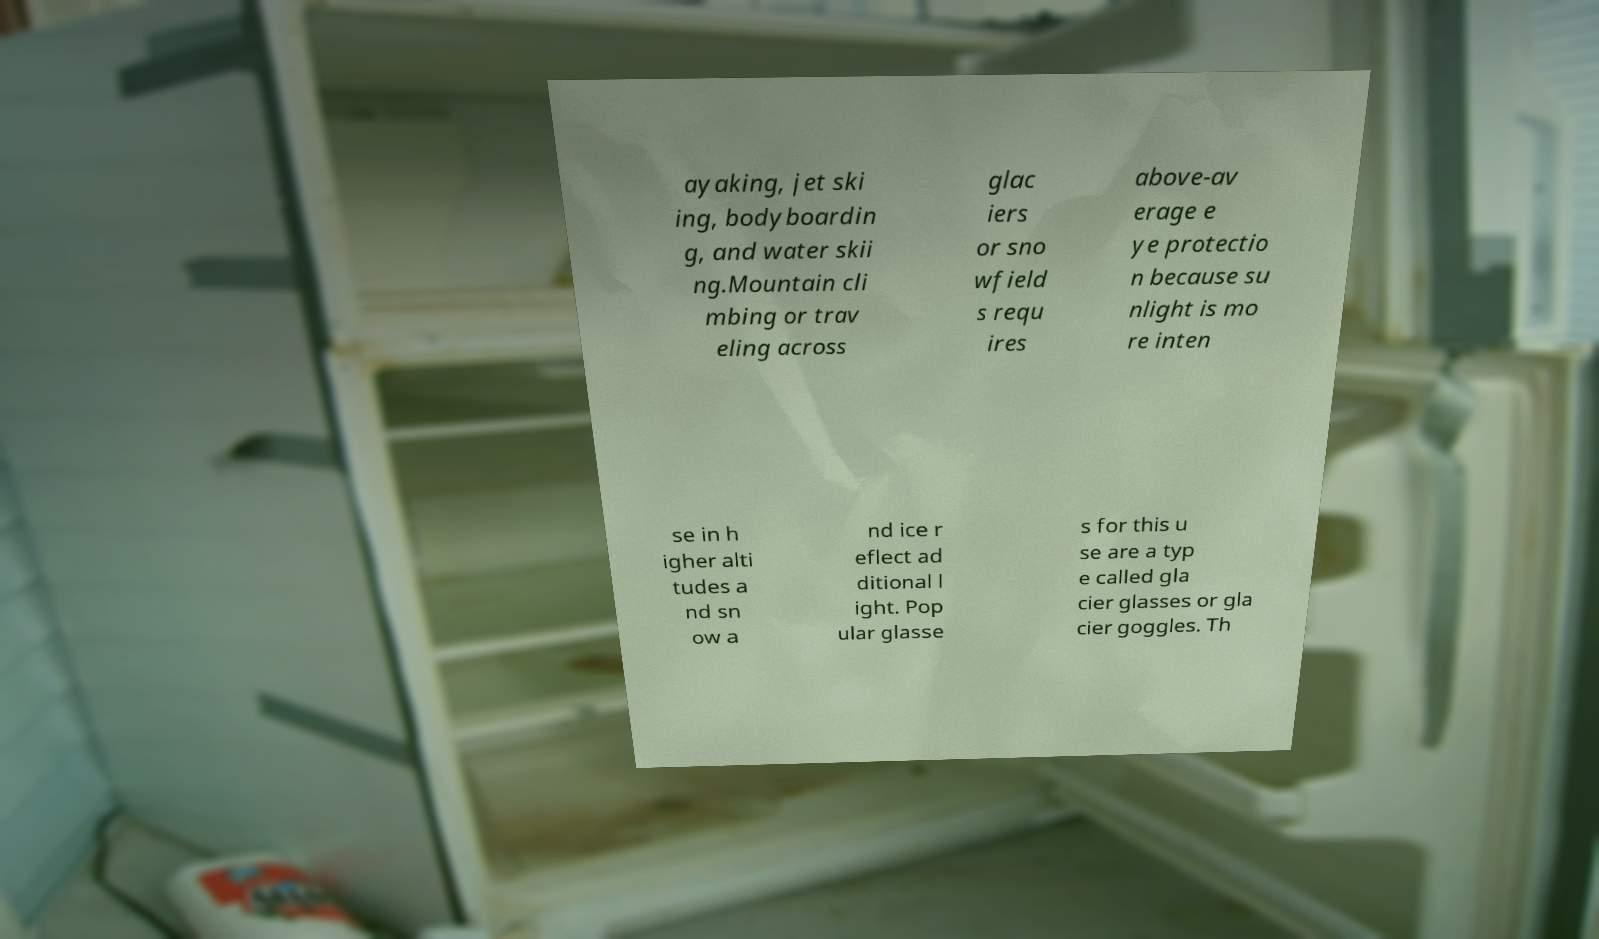Can you read and provide the text displayed in the image?This photo seems to have some interesting text. Can you extract and type it out for me? ayaking, jet ski ing, bodyboardin g, and water skii ng.Mountain cli mbing or trav eling across glac iers or sno wfield s requ ires above-av erage e ye protectio n because su nlight is mo re inten se in h igher alti tudes a nd sn ow a nd ice r eflect ad ditional l ight. Pop ular glasse s for this u se are a typ e called gla cier glasses or gla cier goggles. Th 